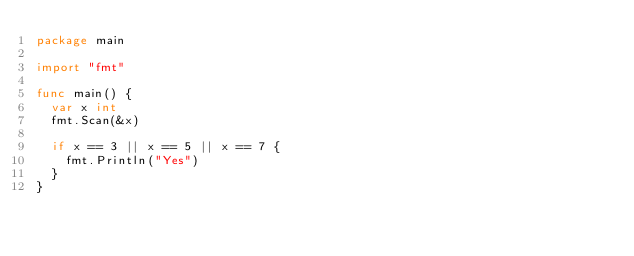<code> <loc_0><loc_0><loc_500><loc_500><_Go_>package main

import "fmt"

func main() {
	var x int
	fmt.Scan(&x)

	if x == 3 || x == 5 || x == 7 {
		fmt.Println("Yes")
	}
}
</code> 